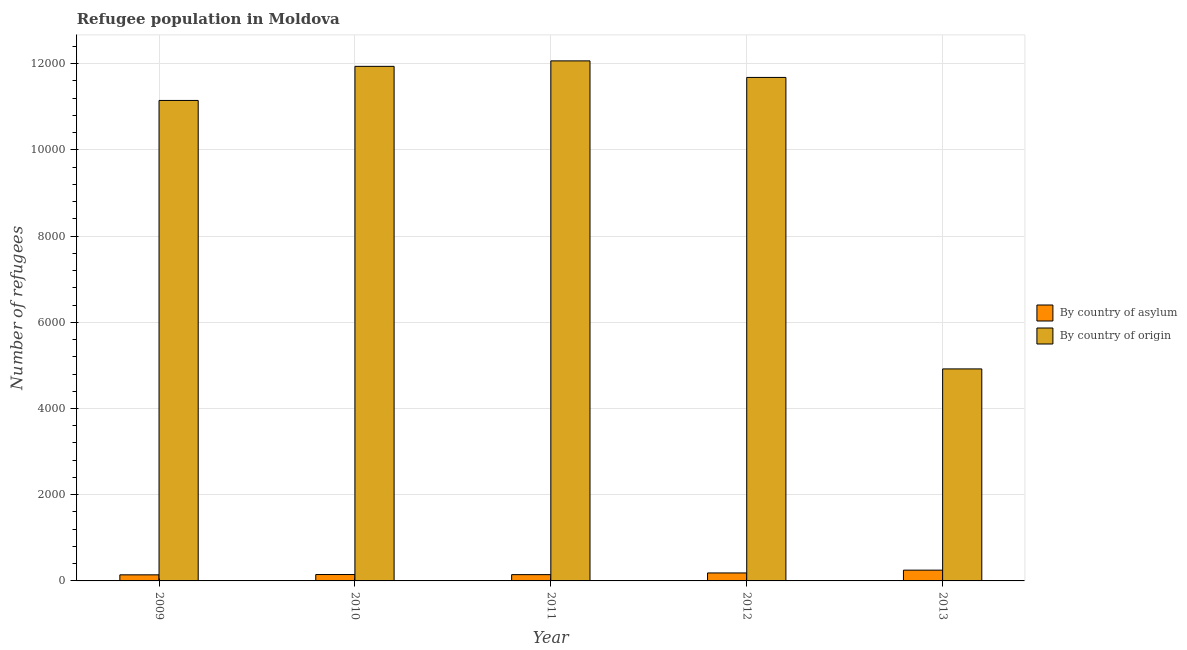Are the number of bars on each tick of the X-axis equal?
Give a very brief answer. Yes. How many bars are there on the 3rd tick from the left?
Your answer should be very brief. 2. What is the number of refugees by country of origin in 2013?
Ensure brevity in your answer.  4918. Across all years, what is the maximum number of refugees by country of asylum?
Make the answer very short. 250. Across all years, what is the minimum number of refugees by country of asylum?
Your answer should be very brief. 141. What is the total number of refugees by country of asylum in the graph?
Offer a terse response. 870. What is the difference between the number of refugees by country of asylum in 2009 and that in 2011?
Make the answer very short. -5. What is the difference between the number of refugees by country of origin in 2011 and the number of refugees by country of asylum in 2010?
Provide a succinct answer. 127. What is the average number of refugees by country of asylum per year?
Give a very brief answer. 174. What is the ratio of the number of refugees by country of asylum in 2009 to that in 2010?
Your answer should be compact. 0.95. Is the difference between the number of refugees by country of origin in 2009 and 2011 greater than the difference between the number of refugees by country of asylum in 2009 and 2011?
Give a very brief answer. No. What is the difference between the highest and the second highest number of refugees by country of origin?
Offer a very short reply. 127. What is the difference between the highest and the lowest number of refugees by country of asylum?
Make the answer very short. 109. Is the sum of the number of refugees by country of asylum in 2009 and 2012 greater than the maximum number of refugees by country of origin across all years?
Provide a succinct answer. Yes. What does the 2nd bar from the left in 2010 represents?
Provide a short and direct response. By country of origin. What does the 2nd bar from the right in 2011 represents?
Your answer should be compact. By country of asylum. Are all the bars in the graph horizontal?
Give a very brief answer. No. Where does the legend appear in the graph?
Your answer should be compact. Center right. What is the title of the graph?
Your answer should be compact. Refugee population in Moldova. Does "Primary education" appear as one of the legend labels in the graph?
Make the answer very short. No. What is the label or title of the X-axis?
Offer a terse response. Year. What is the label or title of the Y-axis?
Provide a short and direct response. Number of refugees. What is the Number of refugees of By country of asylum in 2009?
Your answer should be very brief. 141. What is the Number of refugees of By country of origin in 2009?
Give a very brief answer. 1.11e+04. What is the Number of refugees in By country of asylum in 2010?
Provide a succinct answer. 148. What is the Number of refugees in By country of origin in 2010?
Your answer should be very brief. 1.19e+04. What is the Number of refugees in By country of asylum in 2011?
Give a very brief answer. 146. What is the Number of refugees of By country of origin in 2011?
Provide a succinct answer. 1.21e+04. What is the Number of refugees in By country of asylum in 2012?
Give a very brief answer. 185. What is the Number of refugees in By country of origin in 2012?
Your answer should be compact. 1.17e+04. What is the Number of refugees in By country of asylum in 2013?
Make the answer very short. 250. What is the Number of refugees in By country of origin in 2013?
Offer a terse response. 4918. Across all years, what is the maximum Number of refugees of By country of asylum?
Offer a very short reply. 250. Across all years, what is the maximum Number of refugees of By country of origin?
Ensure brevity in your answer.  1.21e+04. Across all years, what is the minimum Number of refugees in By country of asylum?
Ensure brevity in your answer.  141. Across all years, what is the minimum Number of refugees in By country of origin?
Your answer should be very brief. 4918. What is the total Number of refugees in By country of asylum in the graph?
Keep it short and to the point. 870. What is the total Number of refugees of By country of origin in the graph?
Offer a very short reply. 5.17e+04. What is the difference between the Number of refugees in By country of origin in 2009 and that in 2010?
Your response must be concise. -791. What is the difference between the Number of refugees in By country of origin in 2009 and that in 2011?
Keep it short and to the point. -918. What is the difference between the Number of refugees of By country of asylum in 2009 and that in 2012?
Keep it short and to the point. -44. What is the difference between the Number of refugees in By country of origin in 2009 and that in 2012?
Ensure brevity in your answer.  -534. What is the difference between the Number of refugees in By country of asylum in 2009 and that in 2013?
Provide a succinct answer. -109. What is the difference between the Number of refugees of By country of origin in 2009 and that in 2013?
Ensure brevity in your answer.  6228. What is the difference between the Number of refugees of By country of origin in 2010 and that in 2011?
Your answer should be very brief. -127. What is the difference between the Number of refugees of By country of asylum in 2010 and that in 2012?
Provide a succinct answer. -37. What is the difference between the Number of refugees in By country of origin in 2010 and that in 2012?
Your answer should be compact. 257. What is the difference between the Number of refugees of By country of asylum in 2010 and that in 2013?
Provide a short and direct response. -102. What is the difference between the Number of refugees of By country of origin in 2010 and that in 2013?
Give a very brief answer. 7019. What is the difference between the Number of refugees in By country of asylum in 2011 and that in 2012?
Make the answer very short. -39. What is the difference between the Number of refugees in By country of origin in 2011 and that in 2012?
Keep it short and to the point. 384. What is the difference between the Number of refugees of By country of asylum in 2011 and that in 2013?
Keep it short and to the point. -104. What is the difference between the Number of refugees of By country of origin in 2011 and that in 2013?
Make the answer very short. 7146. What is the difference between the Number of refugees in By country of asylum in 2012 and that in 2013?
Keep it short and to the point. -65. What is the difference between the Number of refugees of By country of origin in 2012 and that in 2013?
Provide a succinct answer. 6762. What is the difference between the Number of refugees in By country of asylum in 2009 and the Number of refugees in By country of origin in 2010?
Offer a very short reply. -1.18e+04. What is the difference between the Number of refugees in By country of asylum in 2009 and the Number of refugees in By country of origin in 2011?
Ensure brevity in your answer.  -1.19e+04. What is the difference between the Number of refugees of By country of asylum in 2009 and the Number of refugees of By country of origin in 2012?
Your response must be concise. -1.15e+04. What is the difference between the Number of refugees of By country of asylum in 2009 and the Number of refugees of By country of origin in 2013?
Offer a terse response. -4777. What is the difference between the Number of refugees of By country of asylum in 2010 and the Number of refugees of By country of origin in 2011?
Ensure brevity in your answer.  -1.19e+04. What is the difference between the Number of refugees in By country of asylum in 2010 and the Number of refugees in By country of origin in 2012?
Provide a succinct answer. -1.15e+04. What is the difference between the Number of refugees of By country of asylum in 2010 and the Number of refugees of By country of origin in 2013?
Offer a terse response. -4770. What is the difference between the Number of refugees of By country of asylum in 2011 and the Number of refugees of By country of origin in 2012?
Your answer should be very brief. -1.15e+04. What is the difference between the Number of refugees of By country of asylum in 2011 and the Number of refugees of By country of origin in 2013?
Your answer should be compact. -4772. What is the difference between the Number of refugees in By country of asylum in 2012 and the Number of refugees in By country of origin in 2013?
Give a very brief answer. -4733. What is the average Number of refugees of By country of asylum per year?
Give a very brief answer. 174. What is the average Number of refugees in By country of origin per year?
Your answer should be compact. 1.03e+04. In the year 2009, what is the difference between the Number of refugees of By country of asylum and Number of refugees of By country of origin?
Your answer should be compact. -1.10e+04. In the year 2010, what is the difference between the Number of refugees of By country of asylum and Number of refugees of By country of origin?
Provide a short and direct response. -1.18e+04. In the year 2011, what is the difference between the Number of refugees of By country of asylum and Number of refugees of By country of origin?
Your response must be concise. -1.19e+04. In the year 2012, what is the difference between the Number of refugees in By country of asylum and Number of refugees in By country of origin?
Give a very brief answer. -1.15e+04. In the year 2013, what is the difference between the Number of refugees in By country of asylum and Number of refugees in By country of origin?
Ensure brevity in your answer.  -4668. What is the ratio of the Number of refugees in By country of asylum in 2009 to that in 2010?
Your answer should be compact. 0.95. What is the ratio of the Number of refugees of By country of origin in 2009 to that in 2010?
Your response must be concise. 0.93. What is the ratio of the Number of refugees of By country of asylum in 2009 to that in 2011?
Provide a succinct answer. 0.97. What is the ratio of the Number of refugees of By country of origin in 2009 to that in 2011?
Your response must be concise. 0.92. What is the ratio of the Number of refugees in By country of asylum in 2009 to that in 2012?
Offer a very short reply. 0.76. What is the ratio of the Number of refugees of By country of origin in 2009 to that in 2012?
Offer a very short reply. 0.95. What is the ratio of the Number of refugees in By country of asylum in 2009 to that in 2013?
Your response must be concise. 0.56. What is the ratio of the Number of refugees in By country of origin in 2009 to that in 2013?
Offer a very short reply. 2.27. What is the ratio of the Number of refugees of By country of asylum in 2010 to that in 2011?
Ensure brevity in your answer.  1.01. What is the ratio of the Number of refugees in By country of origin in 2010 to that in 2011?
Your answer should be compact. 0.99. What is the ratio of the Number of refugees in By country of asylum in 2010 to that in 2013?
Offer a terse response. 0.59. What is the ratio of the Number of refugees of By country of origin in 2010 to that in 2013?
Your answer should be compact. 2.43. What is the ratio of the Number of refugees in By country of asylum in 2011 to that in 2012?
Make the answer very short. 0.79. What is the ratio of the Number of refugees in By country of origin in 2011 to that in 2012?
Make the answer very short. 1.03. What is the ratio of the Number of refugees in By country of asylum in 2011 to that in 2013?
Your answer should be very brief. 0.58. What is the ratio of the Number of refugees in By country of origin in 2011 to that in 2013?
Provide a succinct answer. 2.45. What is the ratio of the Number of refugees of By country of asylum in 2012 to that in 2013?
Provide a short and direct response. 0.74. What is the ratio of the Number of refugees in By country of origin in 2012 to that in 2013?
Make the answer very short. 2.37. What is the difference between the highest and the second highest Number of refugees of By country of asylum?
Your response must be concise. 65. What is the difference between the highest and the second highest Number of refugees of By country of origin?
Offer a terse response. 127. What is the difference between the highest and the lowest Number of refugees in By country of asylum?
Offer a terse response. 109. What is the difference between the highest and the lowest Number of refugees of By country of origin?
Ensure brevity in your answer.  7146. 